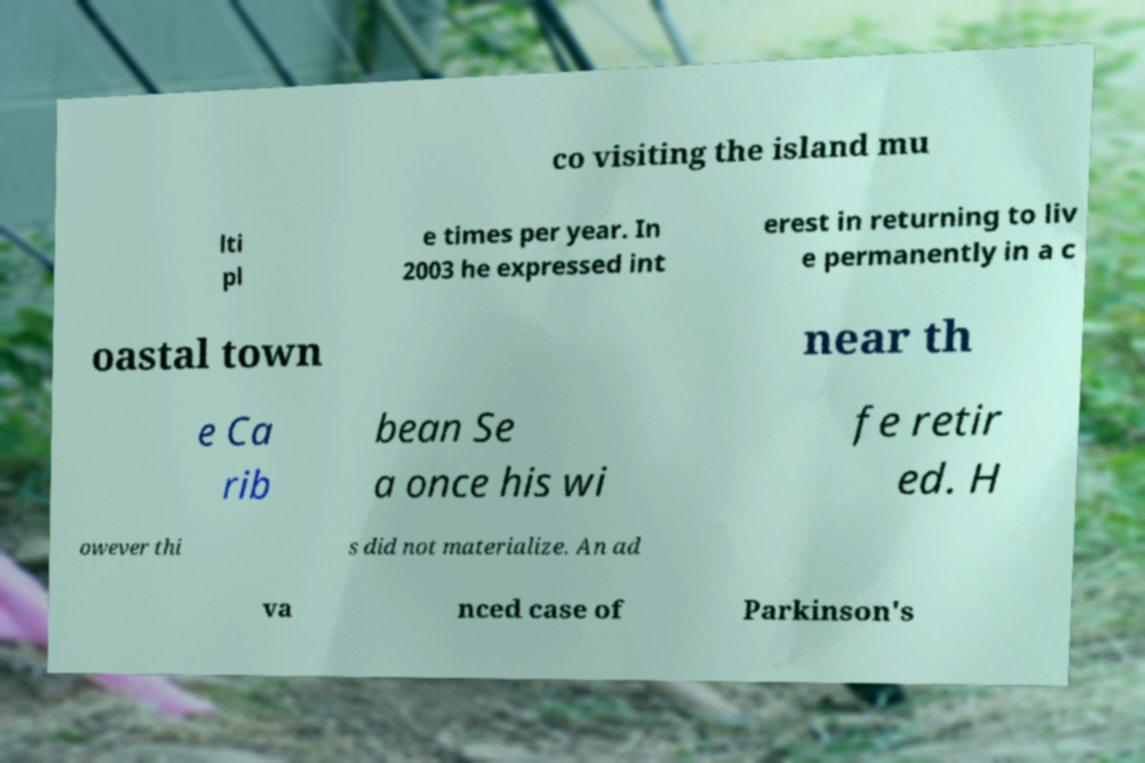For documentation purposes, I need the text within this image transcribed. Could you provide that? co visiting the island mu lti pl e times per year. In 2003 he expressed int erest in returning to liv e permanently in a c oastal town near th e Ca rib bean Se a once his wi fe retir ed. H owever thi s did not materialize. An ad va nced case of Parkinson's 